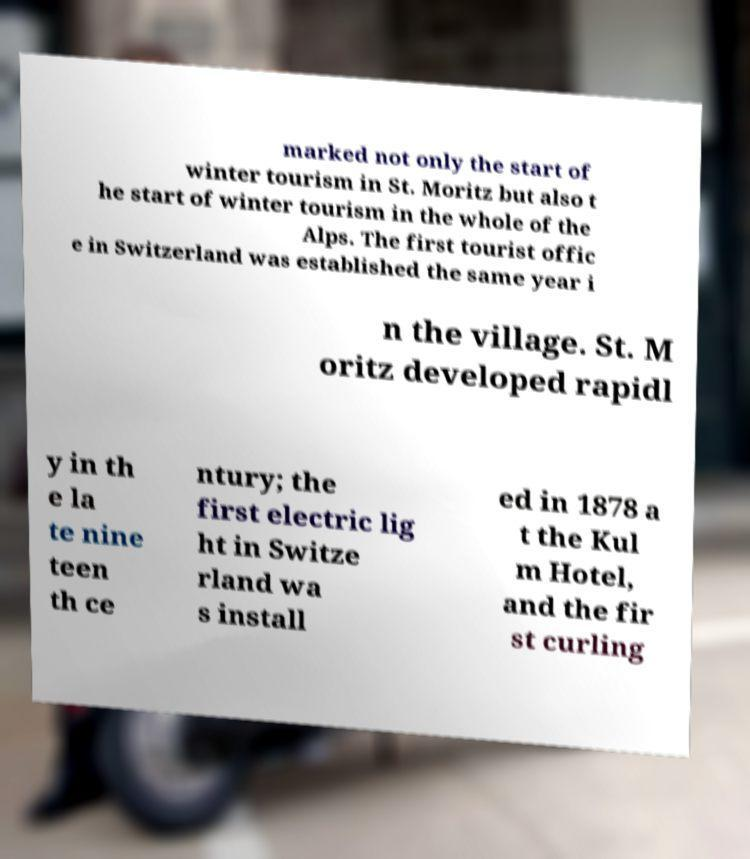I need the written content from this picture converted into text. Can you do that? marked not only the start of winter tourism in St. Moritz but also t he start of winter tourism in the whole of the Alps. The first tourist offic e in Switzerland was established the same year i n the village. St. M oritz developed rapidl y in th e la te nine teen th ce ntury; the first electric lig ht in Switze rland wa s install ed in 1878 a t the Kul m Hotel, and the fir st curling 